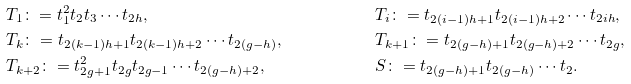<formula> <loc_0><loc_0><loc_500><loc_500>& T _ { 1 } \colon = t _ { 1 } ^ { 2 } t _ { 2 } t _ { 3 } \cdots t _ { 2 h } , & & T _ { i } \colon = t _ { 2 ( i - 1 ) h + 1 } t _ { 2 ( i - 1 ) h + 2 } \cdots t _ { 2 i h } , & \\ & T _ { k } \colon = t _ { 2 ( k - 1 ) h + 1 } t _ { 2 ( k - 1 ) h + 2 } \cdots t _ { 2 ( g - h ) } , & & T _ { k + 1 } \colon = t _ { 2 ( g - h ) + 1 } t _ { 2 ( g - h ) + 2 } \cdots t _ { 2 g } , & \\ & T _ { k + 2 } \colon = t _ { 2 g + 1 } ^ { 2 } t _ { 2 g } t _ { 2 g - 1 } \cdots t _ { 2 ( g - h ) + 2 } , & & S \colon = t _ { 2 ( g - h ) + 1 } t _ { 2 ( g - h ) } \cdots t _ { 2 } . &</formula> 